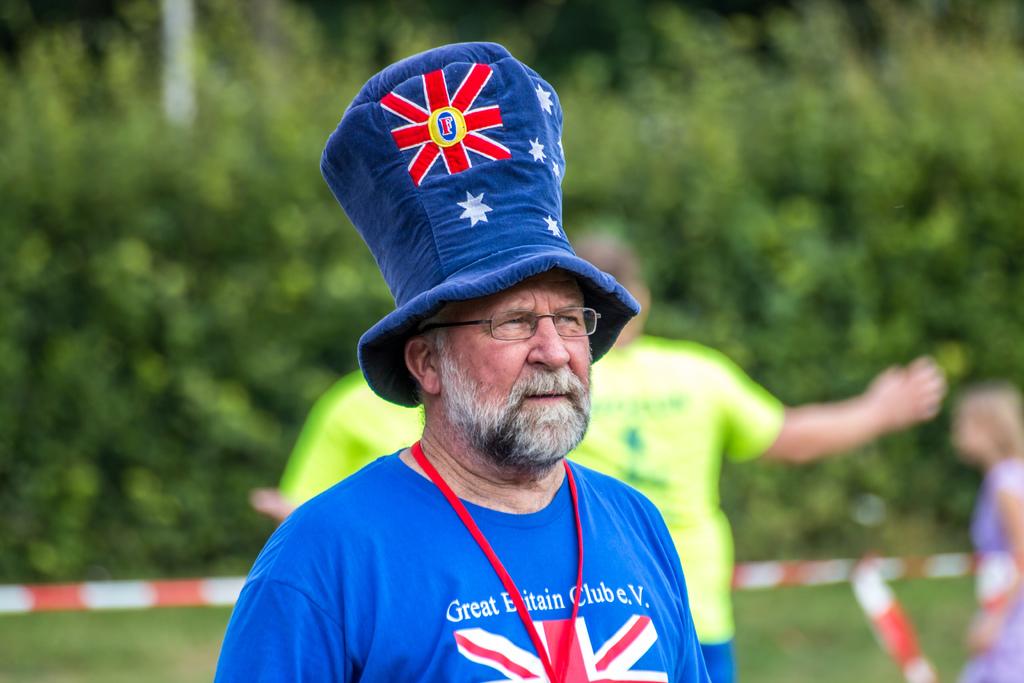What is the first word on the mans shirt?
Provide a succinct answer. Great. 